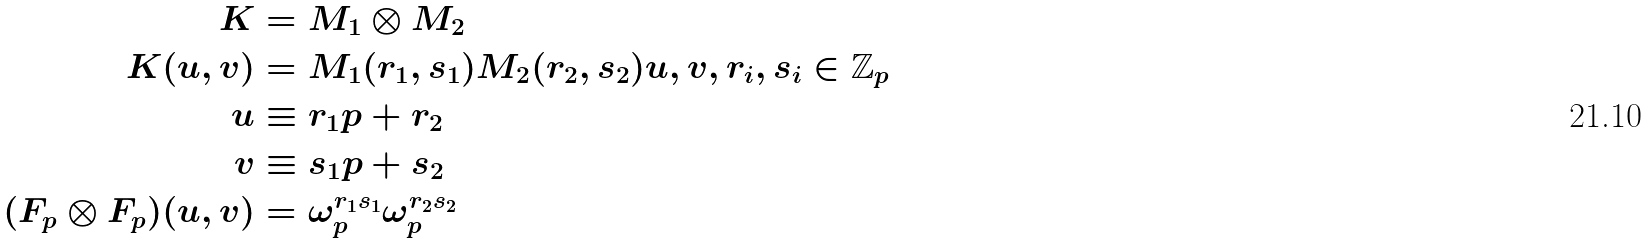Convert formula to latex. <formula><loc_0><loc_0><loc_500><loc_500>K & = M _ { 1 } \otimes M _ { 2 } \\ K ( u , v ) & = M _ { 1 } ( r _ { 1 } , s _ { 1 } ) M _ { 2 } ( r _ { 2 } , s _ { 2 } ) u , v , r _ { i } , s _ { i } \in \mathbb { Z } _ { p } \\ u & \equiv r _ { 1 } p + r _ { 2 } \\ v & \equiv s _ { 1 } p + s _ { 2 } \\ ( F _ { p } \otimes F _ { p } ) ( u , v ) & = \omega _ { p } ^ { r _ { 1 } s _ { 1 } } \omega _ { p } ^ { r _ { 2 } s _ { 2 } }</formula> 